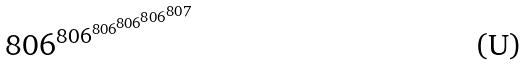<formula> <loc_0><loc_0><loc_500><loc_500>8 0 6 ^ { 8 0 6 ^ { 8 0 6 ^ { 8 0 6 ^ { 8 0 6 ^ { 8 0 7 } } } } }</formula> 